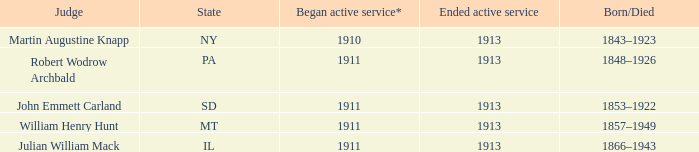Who was the judge for the state SD? John Emmett Carland. 